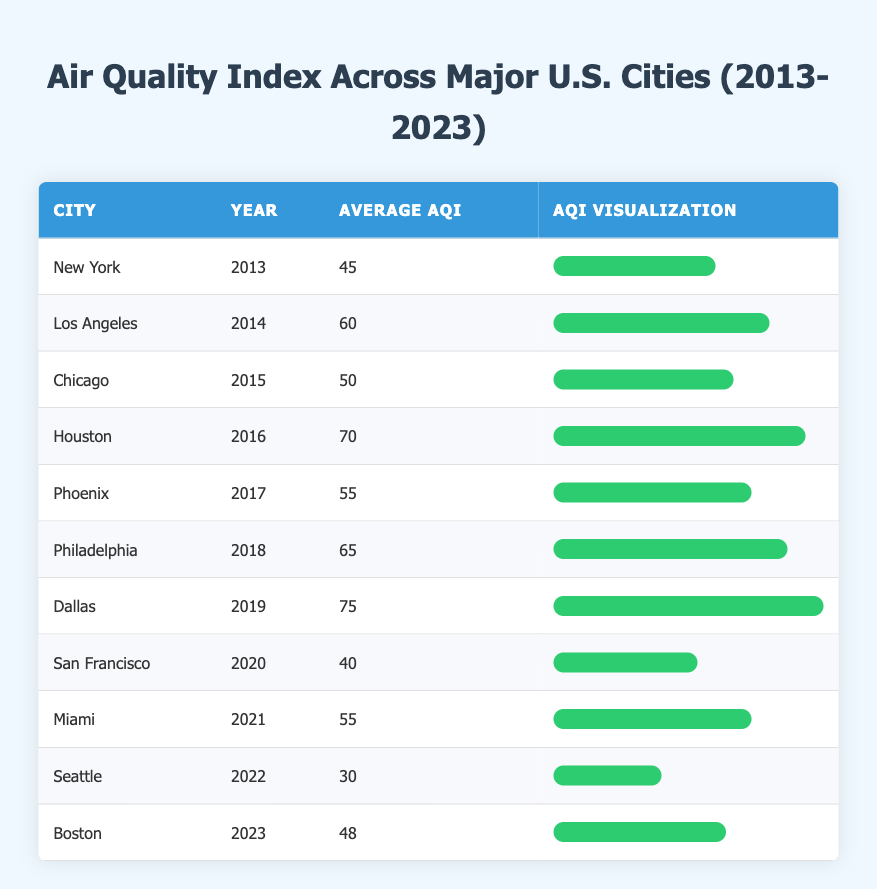What was the average AQI for Chicago in 2015? The table shows that Chicago had an average AQI of 50 in the year 2015, which can be found directly in the row corresponding to Chicago and the year 2015.
Answer: 50 Which city had the highest average AQI and what was the value? Looking through the table, Dallas in 2019 had the highest average AQI of 75, as seen in the specific row for Dallas for that year.
Answer: 75 Did Miami have a better average AQI than New York in 2021 and 2013 respectively? Comparing the average AQI values from the table, Miami had an average of 55 in 2021, while New York had 45 in 2013. Since 55 is greater than 45, Miami did have a better AQI than New York during those years.
Answer: Yes What was the average AQI for the years 2016 and 2018 combined? To find the average, first, sum the average AQIs from the table: Houston (70 in 2016) and Philadelphia (65 in 2018). The total is 70 + 65 = 135. There are 2 years, so the average is 135 / 2 = 67.5.
Answer: 67.5 How many cities had an average AQI below 50? From the table, Seattle in 2022 and San Francisco in 2020 had average AQIs of 30 and 40, respectively. Thus, only 2 cities reported an AQI below 50.
Answer: 2 What is the average AQI for all cities over the decade from 2013 to 2023? First, we add all the average AQIs: 45 + 60 + 50 + 70 + 55 + 65 + 75 + 40 + 55 + 30 + 48 =  648. There are 11 cities, so we divide 648 by 11, resulting in an average AQI of about 58.91.
Answer: 58.91 Which city had an average AQI closest to 50, and what was that value? By checking the AQI values in the table, Chicago had an average AQI of 50, which is equal to 50. Therefore, the AQI for Chicago is the closest to 50 since it matches.
Answer: 50 Was the average AQI for Boston in 2023 above the average AQI of Philadelphia in 2018? Boston had an average AQI of 48 in 2023, while Philadelphia had an average AQI of 65 in 2018. Since 48 is less than 65, Boston's AQI was below Philadelphia's.
Answer: No 